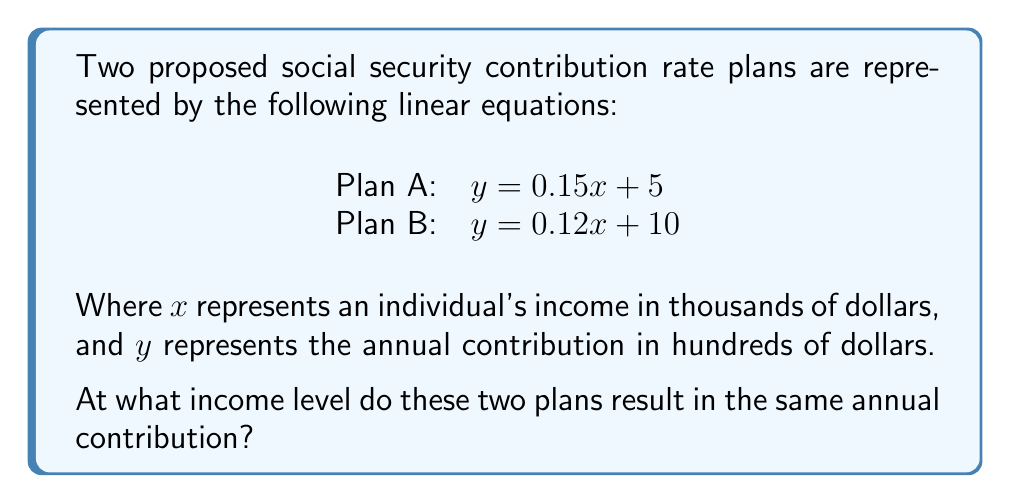Can you solve this math problem? To find the income level where both plans result in the same contribution, we need to find the intersection point of the two lines. This can be done by equating the two equations and solving for $x$.

1) Set the equations equal to each other:
   $0.15x + 5 = 0.12x + 10$

2) Subtract $0.12x$ from both sides:
   $0.03x + 5 = 10$

3) Subtract 5 from both sides:
   $0.03x = 5$

4) Divide both sides by 0.03:
   $x = \frac{5}{0.03} = 166.67$

5) To find the $y$ coordinate (contribution amount), substitute $x = 166.67$ into either equation. Let's use Plan A:
   $y = 0.15(166.67) + 5 = 25 + 5 = 30$

Therefore, the two plans intersect at the point (166.67, 30), which means they result in the same contribution when an individual's income is $166,670, and the annual contribution at this point is $3,000.
Answer: $166,670 annual income 